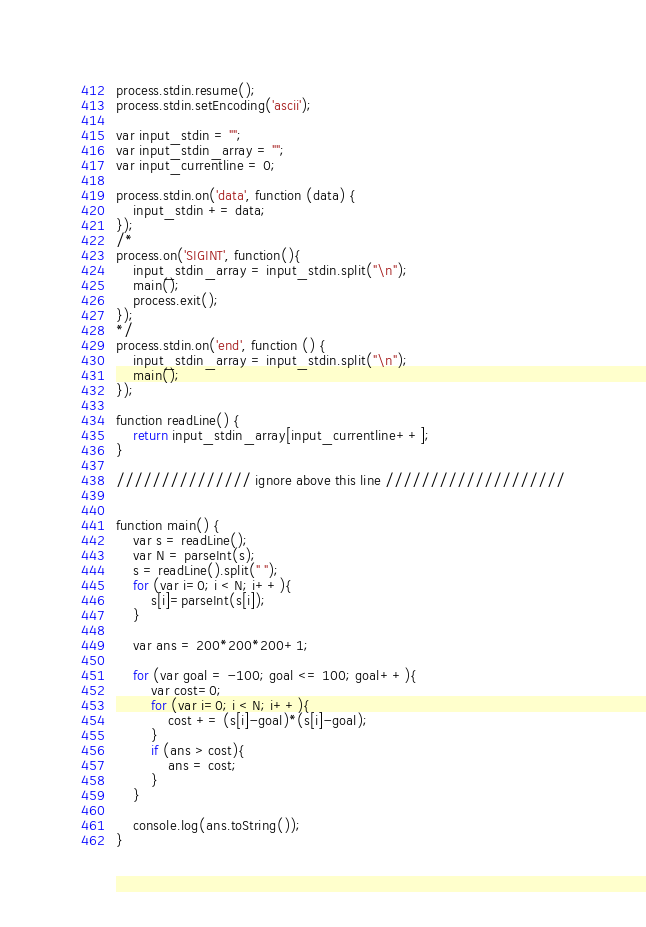<code> <loc_0><loc_0><loc_500><loc_500><_Python_>process.stdin.resume();
process.stdin.setEncoding('ascii');

var input_stdin = "";
var input_stdin_array = "";
var input_currentline = 0;

process.stdin.on('data', function (data) {
    input_stdin += data;
});
/*
process.on('SIGINT', function(){
    input_stdin_array = input_stdin.split("\n");
    main();
    process.exit();
});
*/
process.stdin.on('end', function () {
    input_stdin_array = input_stdin.split("\n");
    main();    
});

function readLine() {
    return input_stdin_array[input_currentline++];
}

/////////////// ignore above this line ////////////////////


function main() {
	var s = readLine();	
	var N = parseInt(s);
    s = readLine().split(" ");
	for (var i=0; i < N; i++){
		s[i]=parseInt(s[i]);
	}
	
	var ans = 200*200*200+1;
	
	for (var goal = -100; goal <= 100; goal++){
		var cost=0;
		for (var i=0; i < N; i++){
			cost += (s[i]-goal)*(s[i]-goal);
		}
		if (ans > cost){
			ans = cost;
		}
	}
	
	console.log(ans.toString());
}</code> 